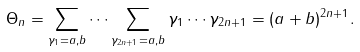Convert formula to latex. <formula><loc_0><loc_0><loc_500><loc_500>\Theta _ { n } = \sum _ { \gamma _ { 1 } = a , b } \cdots \sum _ { \gamma _ { 2 n + 1 } = a , b } \gamma _ { 1 } \cdots \gamma _ { 2 n + 1 } = ( a + b ) ^ { 2 n + 1 } .</formula> 